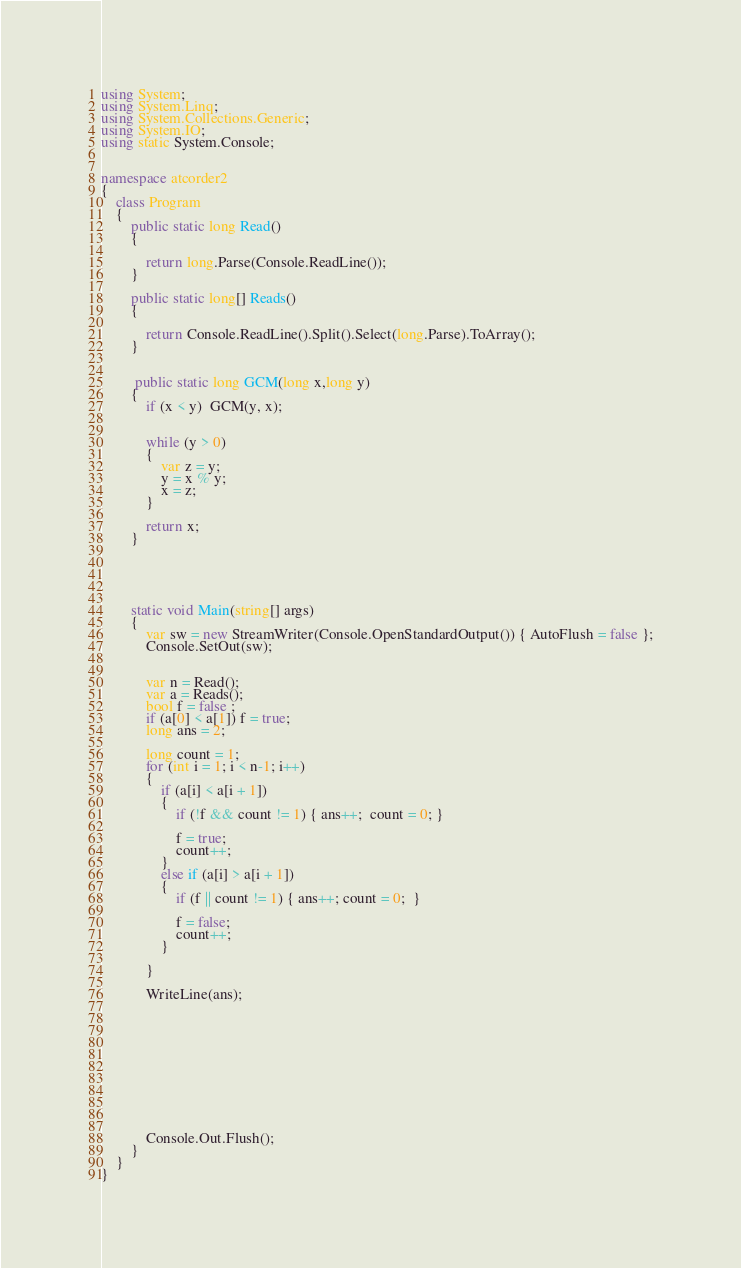<code> <loc_0><loc_0><loc_500><loc_500><_C#_>using System;
using System.Linq;
using System.Collections.Generic;
using System.IO;
using static System.Console;


namespace atcorder2
{
    class Program
    {
        public static long Read()
        {

            return long.Parse(Console.ReadLine());
        }

        public static long[] Reads()
        {

            return Console.ReadLine().Split().Select(long.Parse).ToArray();
        }

       
         public static long GCM(long x,long y)
        {
            if (x < y)  GCM(y, x);


            while (y > 0)
            {
                var z = y;
                y = x % y;
                x = z;
            }
            
            return x;
        }

        



        static void Main(string[] args)
        {
            var sw = new StreamWriter(Console.OpenStandardOutput()) { AutoFlush = false };
            Console.SetOut(sw);


            var n = Read();
            var a = Reads();
            bool f = false ;
            if (a[0] < a[1]) f = true;
            long ans = 2;
            
            long count = 1;
            for (int i = 1; i < n-1; i++)
            {
                if (a[i] < a[i + 1])
                {
                    if (!f && count != 1) { ans++;  count = 0; }

                    f = true;
                    count++;
                }
                else if (a[i] > a[i + 1])
                {
                    if (f || count != 1) { ans++; count = 0;  }

                    f = false;
                    count++;
                }
               
            }
            
            WriteLine(ans);











            Console.Out.Flush();
        }
    }
}


</code> 